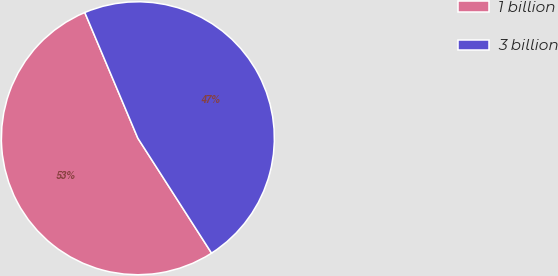Convert chart. <chart><loc_0><loc_0><loc_500><loc_500><pie_chart><fcel>1 billion<fcel>3 billion<nl><fcel>52.72%<fcel>47.28%<nl></chart> 